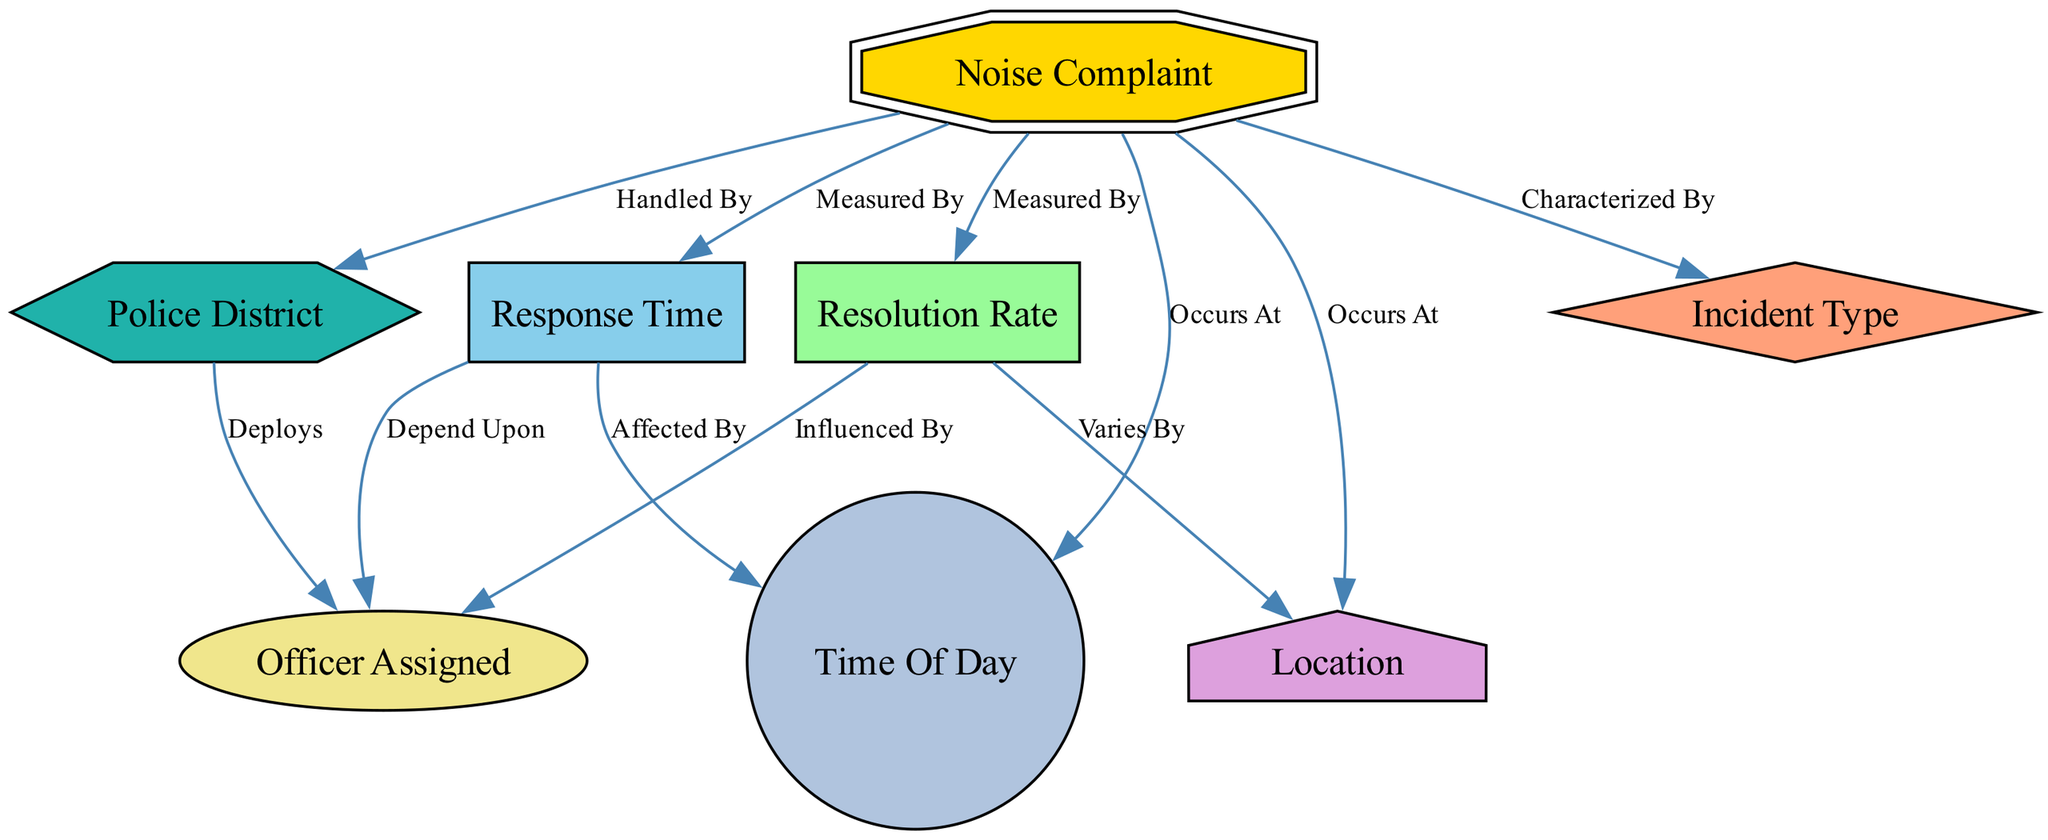What type of node is "Noise Complaint"? The "Noise Complaint" node is categorized as a doubleoctagon shape according to the custom node styles defined in the diagram.
Answer: doubleoctagon How many edges are connected to "Resolution Rate"? There are three edges connected to the "Resolution Rate" node, showing its relationships to "Noise Complaint," "Officer Assigned," and "Location."
Answer: 3 What does "Incident Type" characterize? The edge from "Noise Complaint" to "Incident Type" is labeled "Characterized By," indicating that "Incident Type" provides a characterization of "Noise Complaint."
Answer: Noise Complaint Which node is influenced by "Resolution Rate"? The edge from "Resolution Rate" to "Officer Assigned" is labeled "Influenced By," showing the direct influence that resolution rates have on the officers assigned.
Answer: Officer Assigned What is "Response Time" affected by? The edge from "Response Time" to "Time Of Day" is labeled "Affected By," indicating that the response time for noise complaints can vary depending on the time of day.
Answer: Time Of Day How many nodes are in the diagram? By counting the distinct nodes listed in the data, we find that there are eight nodes in the diagram, including "Noise Complaint," "Response Time," "Resolution Rate," "Incident Type," "Location," "Officer Assigned," "Time Of Day," and "District."
Answer: 8 What does "District" deploy? The edge from "District" to "Officer Assigned" is labeled "Deploys," which means "District" is responsible for the deployment of the officers.
Answer: Officer Assigned What does "Noise Complaint" occurs at? The edges from "Noise Complaint" to both "Location" and "Time Of Day" are labeled as "Occurs At," showing that noise complaints can occur at various locations and times.
Answer: Location, Time Of Day Which node provides metrics for "Response Time"? The edge from "Noise Complaint" to "Response Time" is labeled "Measured By," indicating that response times are assessed or measured based on noise complaints.
Answer: Noise Complaint 